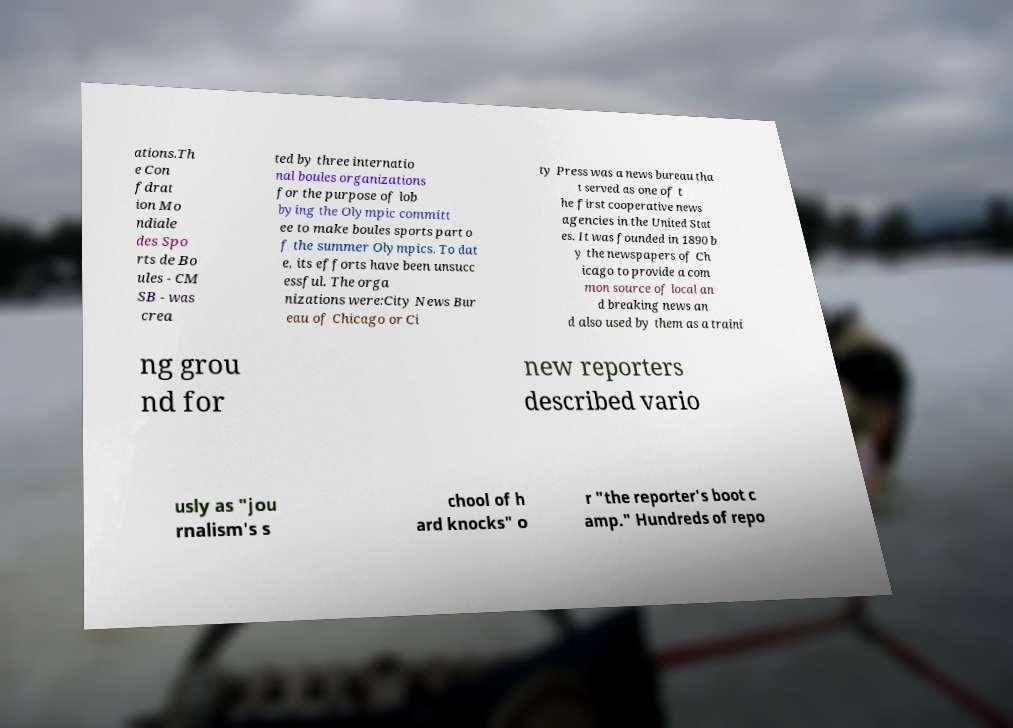Can you read and provide the text displayed in the image?This photo seems to have some interesting text. Can you extract and type it out for me? ations.Th e Con fdrat ion Mo ndiale des Spo rts de Bo ules - CM SB - was crea ted by three internatio nal boules organizations for the purpose of lob bying the Olympic committ ee to make boules sports part o f the summer Olympics. To dat e, its efforts have been unsucc essful. The orga nizations were:City News Bur eau of Chicago or Ci ty Press was a news bureau tha t served as one of t he first cooperative news agencies in the United Stat es. It was founded in 1890 b y the newspapers of Ch icago to provide a com mon source of local an d breaking news an d also used by them as a traini ng grou nd for new reporters described vario usly as "jou rnalism's s chool of h ard knocks" o r "the reporter's boot c amp." Hundreds of repo 